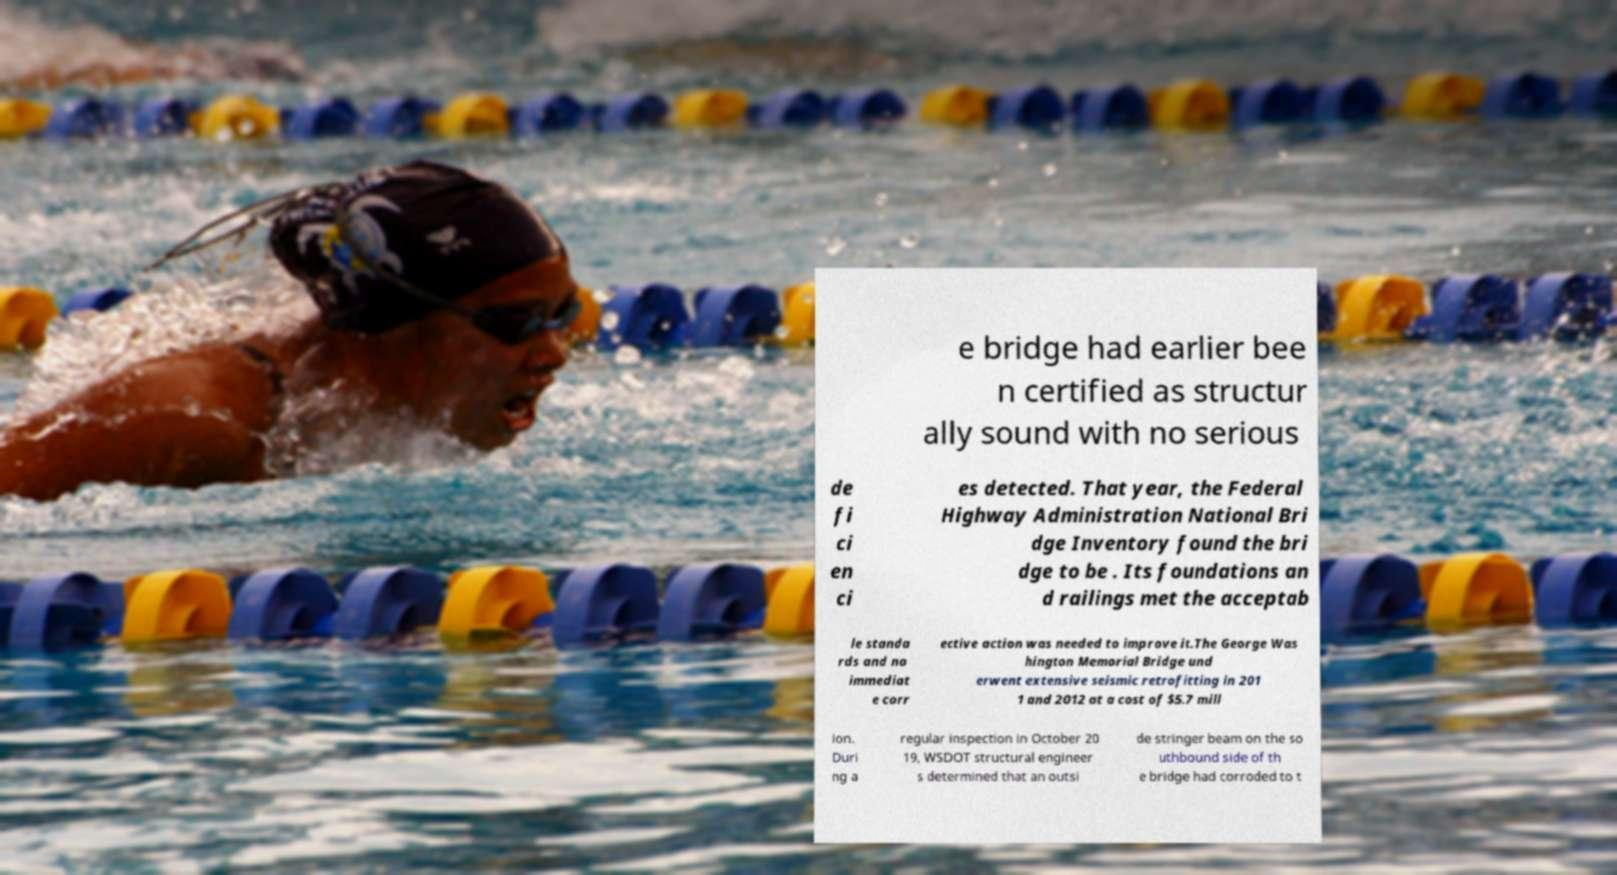Can you read and provide the text displayed in the image?This photo seems to have some interesting text. Can you extract and type it out for me? e bridge had earlier bee n certified as structur ally sound with no serious de fi ci en ci es detected. That year, the Federal Highway Administration National Bri dge Inventory found the bri dge to be . Its foundations an d railings met the acceptab le standa rds and no immediat e corr ective action was needed to improve it.The George Was hington Memorial Bridge und erwent extensive seismic retrofitting in 201 1 and 2012 at a cost of $5.7 mill ion. Duri ng a regular inspection in October 20 19, WSDOT structural engineer s determined that an outsi de stringer beam on the so uthbound side of th e bridge had corroded to t 